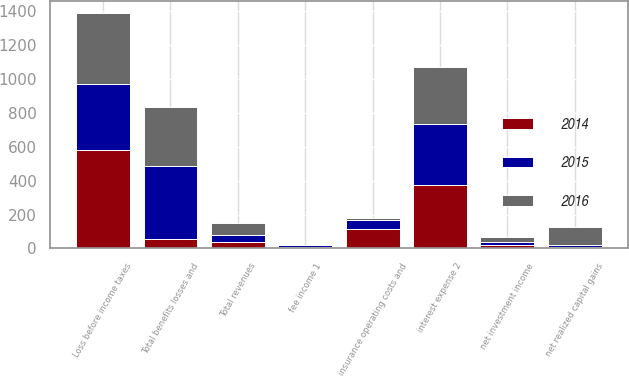<chart> <loc_0><loc_0><loc_500><loc_500><stacked_bar_chart><ecel><fcel>fee income 1<fcel>net investment income<fcel>net realized capital gains<fcel>Total revenues<fcel>insurance operating costs and<fcel>interest expense 2<fcel>Total benefits losses and<fcel>Loss before income taxes<nl><fcel>2016<fcel>4<fcel>31<fcel>103<fcel>68<fcel>14<fcel>339<fcel>353<fcel>421<nl><fcel>2015<fcel>8<fcel>17<fcel>15<fcel>40<fcel>53<fcel>357<fcel>431<fcel>391<nl><fcel>2014<fcel>10<fcel>22<fcel>7<fcel>39<fcel>114<fcel>376<fcel>53<fcel>579<nl></chart> 